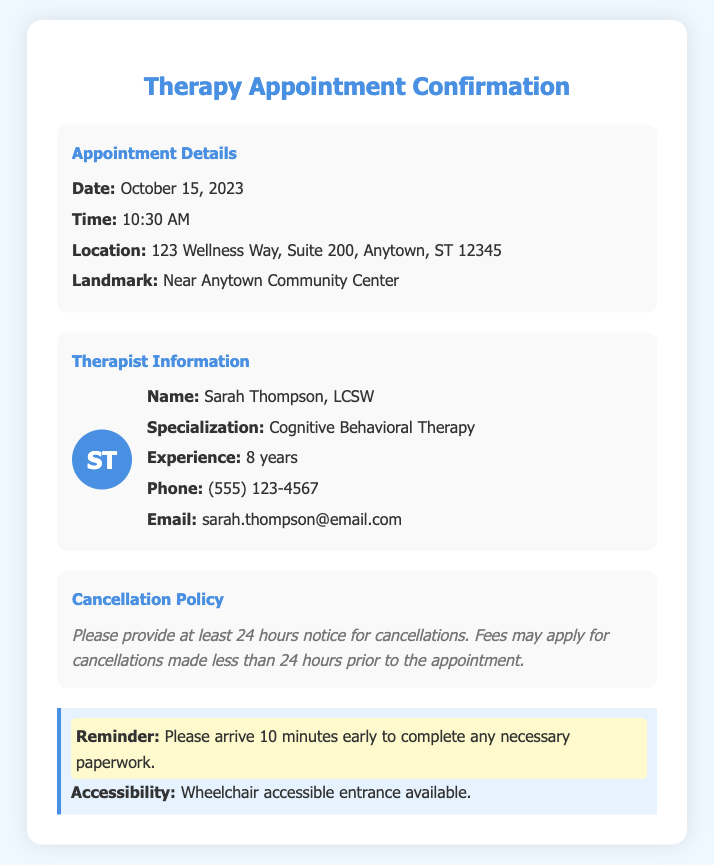What is the appointment date? The appointment date is specified in the document and is mentioned as October 15, 2023.
Answer: October 15, 2023 What is the therapist's specialization? The specialization of the therapist is highlighted in the document under Therapist Information as Cognitive Behavioral Therapy.
Answer: Cognitive Behavioral Therapy What is the therapist's phone number? The phone number for the therapist is provided in the document for contact purposes and is (555) 123-4567.
Answer: (555) 123-4567 What is the cancellation notice required? The cancellation policy indicates the required notice for cancellations is 24 hours.
Answer: 24 hours Where is the appointment location? The location for the appointment is detailed in the document as 123 Wellness Way, Suite 200, Anytown, ST 12345.
Answer: 123 Wellness Way, Suite 200, Anytown, ST 12345 How many years of experience does the therapist have? The experience of the therapist is stated in the document as 8 years in the field.
Answer: 8 years What should clients do before the appointment? The document includes a reminder for clients to arrive early to complete paperwork, which is a specific instruction.
Answer: Arrive 10 minutes early Is the location accessible? The document mentions that the entrance is wheelchair accessible, which addresses accessibility concerns for clients.
Answer: Wheelchair accessible entrance available 